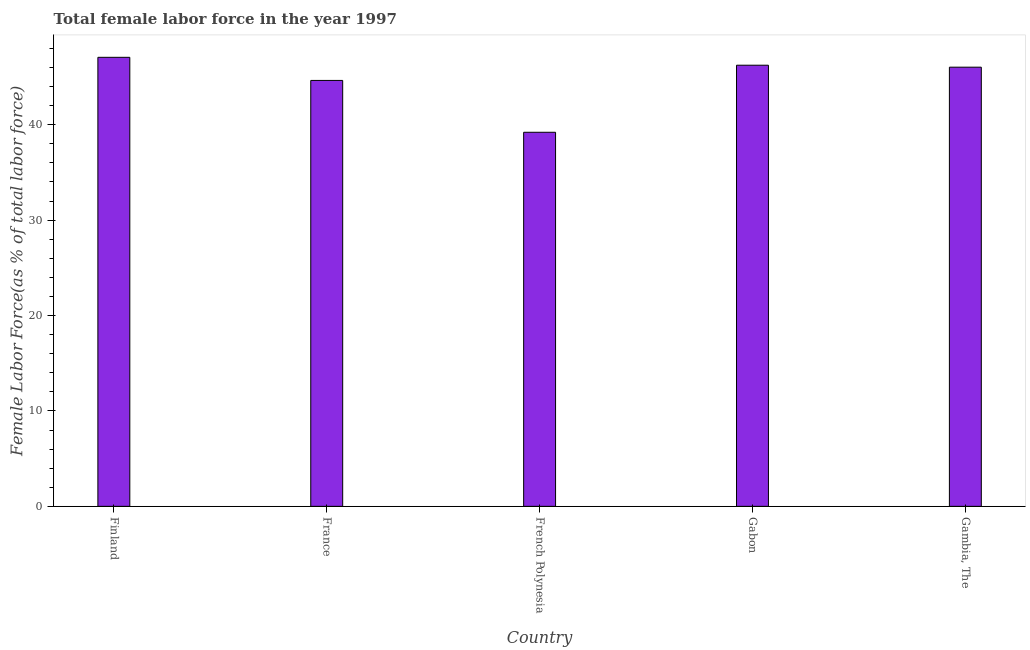Does the graph contain any zero values?
Your response must be concise. No. Does the graph contain grids?
Give a very brief answer. No. What is the title of the graph?
Provide a short and direct response. Total female labor force in the year 1997. What is the label or title of the X-axis?
Provide a succinct answer. Country. What is the label or title of the Y-axis?
Your response must be concise. Female Labor Force(as % of total labor force). What is the total female labor force in Finland?
Offer a very short reply. 47.06. Across all countries, what is the maximum total female labor force?
Keep it short and to the point. 47.06. Across all countries, what is the minimum total female labor force?
Make the answer very short. 39.2. In which country was the total female labor force minimum?
Your answer should be very brief. French Polynesia. What is the sum of the total female labor force?
Make the answer very short. 223.17. What is the difference between the total female labor force in Finland and Gabon?
Keep it short and to the point. 0.83. What is the average total female labor force per country?
Your response must be concise. 44.63. What is the median total female labor force?
Offer a terse response. 46.03. In how many countries, is the total female labor force greater than 2 %?
Offer a very short reply. 5. Is the total female labor force in Gabon less than that in Gambia, The?
Ensure brevity in your answer.  No. Is the difference between the total female labor force in French Polynesia and Gabon greater than the difference between any two countries?
Your answer should be compact. No. What is the difference between the highest and the second highest total female labor force?
Offer a terse response. 0.83. Is the sum of the total female labor force in France and Gabon greater than the maximum total female labor force across all countries?
Provide a short and direct response. Yes. What is the difference between the highest and the lowest total female labor force?
Make the answer very short. 7.86. How many bars are there?
Make the answer very short. 5. Are all the bars in the graph horizontal?
Give a very brief answer. No. Are the values on the major ticks of Y-axis written in scientific E-notation?
Your answer should be very brief. No. What is the Female Labor Force(as % of total labor force) of Finland?
Provide a succinct answer. 47.06. What is the Female Labor Force(as % of total labor force) of France?
Your answer should be very brief. 44.64. What is the Female Labor Force(as % of total labor force) of French Polynesia?
Make the answer very short. 39.2. What is the Female Labor Force(as % of total labor force) in Gabon?
Offer a very short reply. 46.23. What is the Female Labor Force(as % of total labor force) of Gambia, The?
Your answer should be compact. 46.03. What is the difference between the Female Labor Force(as % of total labor force) in Finland and France?
Provide a succinct answer. 2.42. What is the difference between the Female Labor Force(as % of total labor force) in Finland and French Polynesia?
Provide a succinct answer. 7.86. What is the difference between the Female Labor Force(as % of total labor force) in Finland and Gabon?
Provide a succinct answer. 0.83. What is the difference between the Female Labor Force(as % of total labor force) in Finland and Gambia, The?
Your response must be concise. 1.03. What is the difference between the Female Labor Force(as % of total labor force) in France and French Polynesia?
Your response must be concise. 5.43. What is the difference between the Female Labor Force(as % of total labor force) in France and Gabon?
Offer a terse response. -1.59. What is the difference between the Female Labor Force(as % of total labor force) in France and Gambia, The?
Your answer should be very brief. -1.39. What is the difference between the Female Labor Force(as % of total labor force) in French Polynesia and Gabon?
Keep it short and to the point. -7.03. What is the difference between the Female Labor Force(as % of total labor force) in French Polynesia and Gambia, The?
Keep it short and to the point. -6.82. What is the difference between the Female Labor Force(as % of total labor force) in Gabon and Gambia, The?
Your answer should be very brief. 0.21. What is the ratio of the Female Labor Force(as % of total labor force) in Finland to that in France?
Ensure brevity in your answer.  1.05. What is the ratio of the Female Labor Force(as % of total labor force) in Finland to that in French Polynesia?
Provide a short and direct response. 1.2. What is the ratio of the Female Labor Force(as % of total labor force) in Finland to that in Gabon?
Give a very brief answer. 1.02. What is the ratio of the Female Labor Force(as % of total labor force) in Finland to that in Gambia, The?
Provide a succinct answer. 1.02. What is the ratio of the Female Labor Force(as % of total labor force) in France to that in French Polynesia?
Your answer should be compact. 1.14. What is the ratio of the Female Labor Force(as % of total labor force) in France to that in Gabon?
Give a very brief answer. 0.97. What is the ratio of the Female Labor Force(as % of total labor force) in France to that in Gambia, The?
Provide a short and direct response. 0.97. What is the ratio of the Female Labor Force(as % of total labor force) in French Polynesia to that in Gabon?
Give a very brief answer. 0.85. What is the ratio of the Female Labor Force(as % of total labor force) in French Polynesia to that in Gambia, The?
Your answer should be very brief. 0.85. What is the ratio of the Female Labor Force(as % of total labor force) in Gabon to that in Gambia, The?
Your answer should be very brief. 1. 